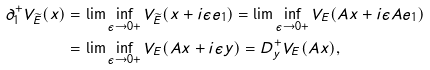<formula> <loc_0><loc_0><loc_500><loc_500>\partial _ { 1 } ^ { + } V _ { \widetilde { E } } ( x ) & = \lim \inf _ { \epsilon \to 0 + } V _ { \widetilde { E } } ( x + i \epsilon e _ { 1 } ) = \lim \inf _ { \epsilon \to 0 + } V _ { E } ( A x + i \epsilon A e _ { 1 } ) \\ & = \lim \inf _ { \epsilon \to 0 + } V _ { E } ( A x + i \epsilon y ) = D _ { y } ^ { + } V _ { E } ( A x ) ,</formula> 